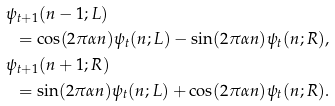<formula> <loc_0><loc_0><loc_500><loc_500>& \psi _ { t + 1 } ( n - 1 ; L ) \\ & \ \ = \cos ( 2 \pi \alpha n ) \psi _ { t } ( n ; L ) - \sin ( 2 \pi \alpha n ) \psi _ { t } ( n ; R ) , \\ & \psi _ { t + 1 } ( n + 1 ; R ) \\ & \ \ = \sin ( 2 \pi \alpha n ) \psi _ { t } ( n ; L ) + \cos ( 2 \pi \alpha n ) \psi _ { t } ( n ; R ) .</formula> 